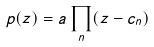<formula> <loc_0><loc_0><loc_500><loc_500>p ( z ) = a \prod _ { n } ( z - c _ { n } )</formula> 